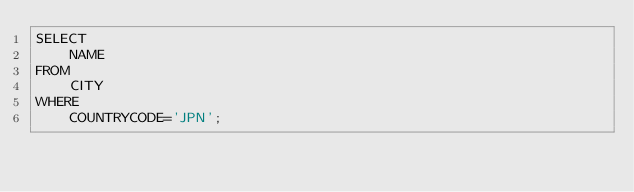<code> <loc_0><loc_0><loc_500><loc_500><_SQL_>SELECT 
    NAME 
FROM 
    CITY
WHERE 
    COUNTRYCODE='JPN';</code> 